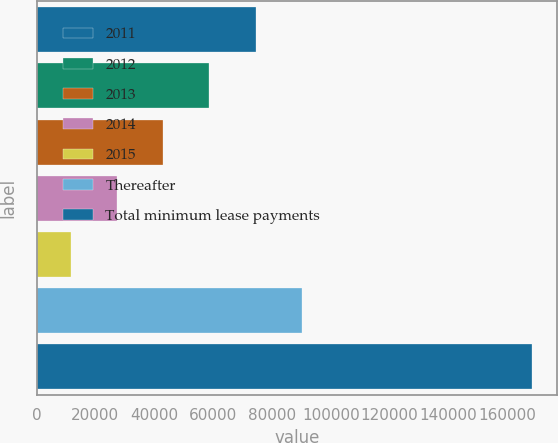Convert chart. <chart><loc_0><loc_0><loc_500><loc_500><bar_chart><fcel>2011<fcel>2012<fcel>2013<fcel>2014<fcel>2015<fcel>Thereafter<fcel>Total minimum lease payments<nl><fcel>74465<fcel>58777.5<fcel>43090<fcel>27402.5<fcel>11715<fcel>90152.5<fcel>168590<nl></chart> 